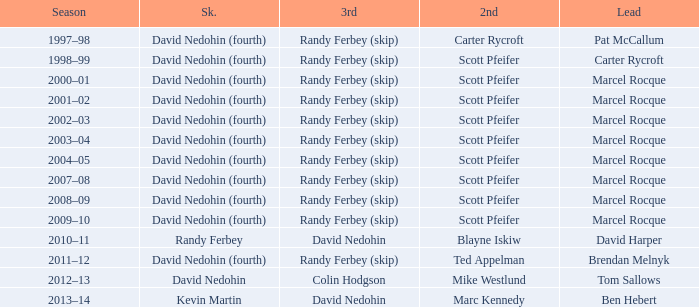Which Skip has a Season of 2002–03? David Nedohin (fourth). 